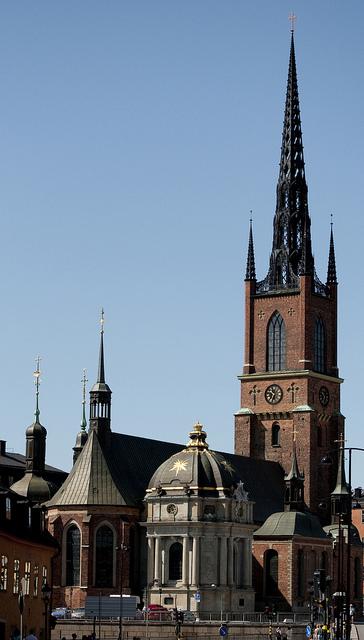What color is the building?
Keep it brief. Brown. What is on the tower?
Answer briefly. Spires. Was this picture taken through a window?
Answer briefly. No. How many steeples are pictured?
Quick response, please. 4. Is there a wedding going on in the background?
Quick response, please. No. Is it a cloudy day?
Write a very short answer. No. Is there a plane in this picture?
Write a very short answer. No. Is the clock large or small?
Quick response, please. Large. What color is the sky?
Be succinct. Blue. Is this a cathedral?
Keep it brief. Yes. What famous landmark is shown?
Give a very brief answer. Cathedral. Is the very noticeable structure centered in the image analog or digital?
Quick response, please. Analog. Is the sun setting?
Write a very short answer. No. 